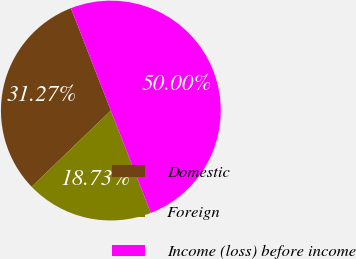Convert chart to OTSL. <chart><loc_0><loc_0><loc_500><loc_500><pie_chart><fcel>Domestic<fcel>Foreign<fcel>Income (loss) before income<nl><fcel>31.27%<fcel>18.73%<fcel>50.0%<nl></chart> 